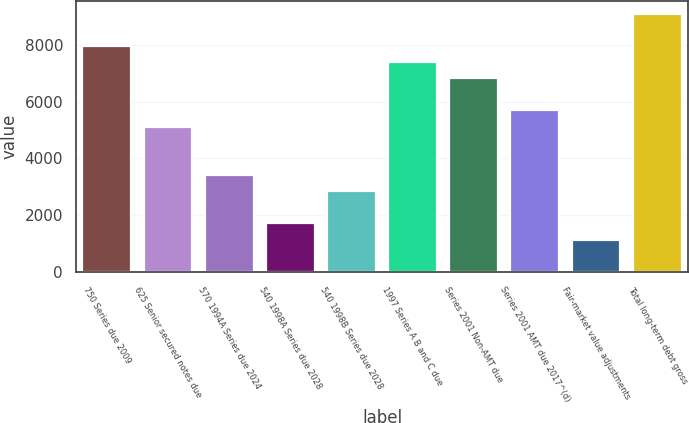Convert chart. <chart><loc_0><loc_0><loc_500><loc_500><bar_chart><fcel>750 Series due 2009<fcel>625 Senior secured notes due<fcel>570 1994A Series due 2024<fcel>540 1998A Series due 2028<fcel>540 1998B Series due 2028<fcel>1997 Series A B and C due<fcel>Series 2001 Non-AMT due<fcel>Series 2001 AMT due 2017^(d)<fcel>Fair-market value adjustments<fcel>Total long-term debt gross<nl><fcel>7966.6<fcel>5122.1<fcel>3415.4<fcel>1708.7<fcel>2846.5<fcel>7397.7<fcel>6828.8<fcel>5691<fcel>1139.8<fcel>9104.4<nl></chart> 